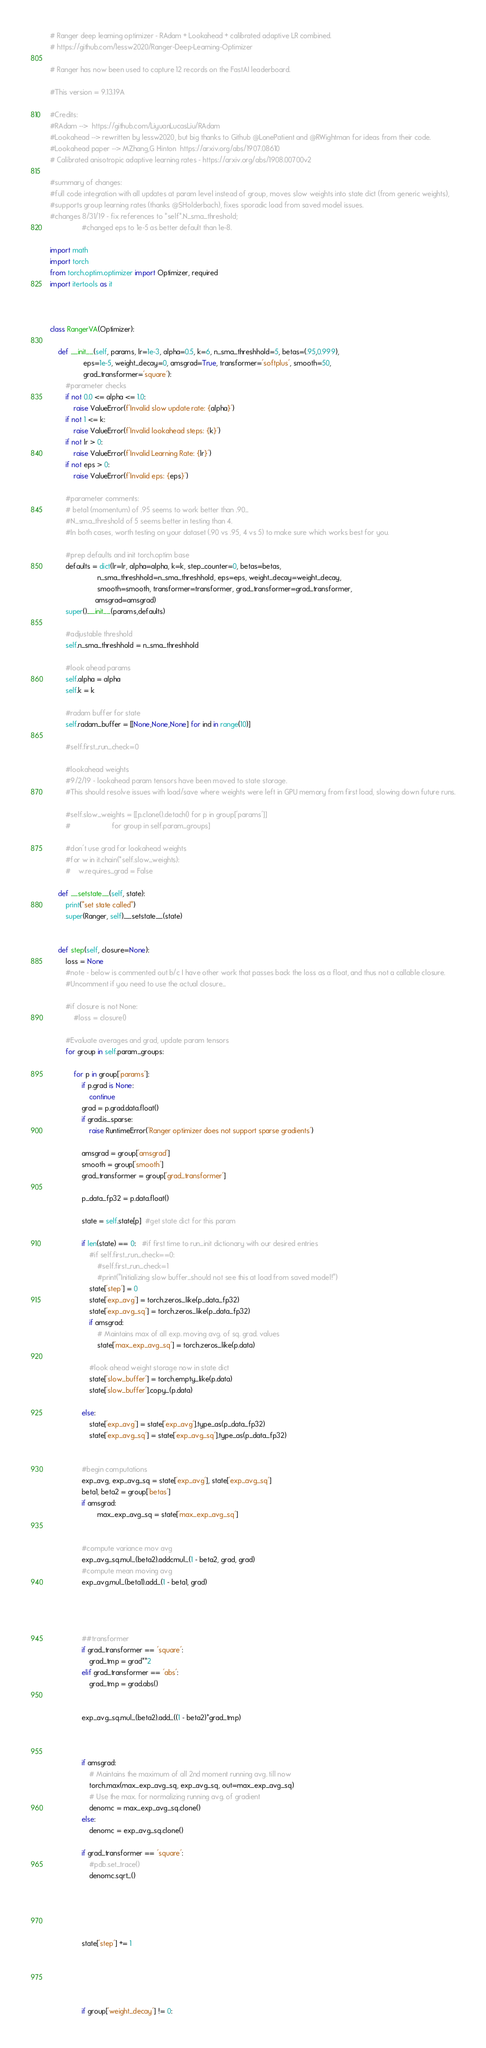Convert code to text. <code><loc_0><loc_0><loc_500><loc_500><_Python_># Ranger deep learning optimizer - RAdam + Lookahead + calibrated adaptive LR combined.
# https://github.com/lessw2020/Ranger-Deep-Learning-Optimizer

# Ranger has now been used to capture 12 records on the FastAI leaderboard.

#This version = 9.13.19A  

#Credits:
#RAdam -->  https://github.com/LiyuanLucasLiu/RAdam
#Lookahead --> rewritten by lessw2020, but big thanks to Github @LonePatient and @RWightman for ideas from their code.
#Lookahead paper --> MZhang,G Hinton  https://arxiv.org/abs/1907.08610
# Calibrated anisotropic adaptive learning rates - https://arxiv.org/abs/1908.00700v2

#summary of changes: 
#full code integration with all updates at param level instead of group, moves slow weights into state dict (from generic weights), 
#supports group learning rates (thanks @SHolderbach), fixes sporadic load from saved model issues.
#changes 8/31/19 - fix references to *self*.N_sma_threshold; 
                #changed eps to 1e-5 as better default than 1e-8.

import math
import torch
from torch.optim.optimizer import Optimizer, required
import itertools as it



class RangerVA(Optimizer):

    def __init__(self, params, lr=1e-3, alpha=0.5, k=6, n_sma_threshhold=5, betas=(.95,0.999), 
                 eps=1e-5, weight_decay=0, amsgrad=True, transformer='softplus', smooth=50,
                 grad_transformer='square'):
        #parameter checks
        if not 0.0 <= alpha <= 1.0:
            raise ValueError(f'Invalid slow update rate: {alpha}')
        if not 1 <= k:
            raise ValueError(f'Invalid lookahead steps: {k}')
        if not lr > 0:
            raise ValueError(f'Invalid Learning Rate: {lr}')
        if not eps > 0:
            raise ValueError(f'Invalid eps: {eps}')

        #parameter comments:
        # beta1 (momentum) of .95 seems to work better than .90...
        #N_sma_threshold of 5 seems better in testing than 4.
        #In both cases, worth testing on your dataset (.90 vs .95, 4 vs 5) to make sure which works best for you.

        #prep defaults and init torch.optim base
        defaults = dict(lr=lr, alpha=alpha, k=k, step_counter=0, betas=betas, 
                        n_sma_threshhold=n_sma_threshhold, eps=eps, weight_decay=weight_decay,
                        smooth=smooth, transformer=transformer, grad_transformer=grad_transformer,
                       amsgrad=amsgrad)
        super().__init__(params,defaults)

        #adjustable threshold
        self.n_sma_threshhold = n_sma_threshhold   

        #look ahead params
        self.alpha = alpha
        self.k = k 

        #radam buffer for state
        self.radam_buffer = [[None,None,None] for ind in range(10)]

        #self.first_run_check=0

        #lookahead weights
        #9/2/19 - lookahead param tensors have been moved to state storage.  
        #This should resolve issues with load/save where weights were left in GPU memory from first load, slowing down future runs.

        #self.slow_weights = [[p.clone().detach() for p in group['params']]
        #                     for group in self.param_groups]

        #don't use grad for lookahead weights
        #for w in it.chain(*self.slow_weights):
        #    w.requires_grad = False

    def __setstate__(self, state):
        print("set state called")
        super(Ranger, self).__setstate__(state)


    def step(self, closure=None):
        loss = None
        #note - below is commented out b/c I have other work that passes back the loss as a float, and thus not a callable closure.  
        #Uncomment if you need to use the actual closure...

        #if closure is not None:
            #loss = closure()

        #Evaluate averages and grad, update param tensors
        for group in self.param_groups:

            for p in group['params']:
                if p.grad is None:
                    continue
                grad = p.grad.data.float()
                if grad.is_sparse:
                    raise RuntimeError('Ranger optimizer does not support sparse gradients')
                
                amsgrad = group['amsgrad']
                smooth = group['smooth']
                grad_transformer = group['grad_transformer']

                p_data_fp32 = p.data.float()

                state = self.state[p]  #get state dict for this param

                if len(state) == 0:   #if first time to run...init dictionary with our desired entries
                    #if self.first_run_check==0:
                        #self.first_run_check=1
                        #print("Initializing slow buffer...should not see this at load from saved model!")
                    state['step'] = 0
                    state['exp_avg'] = torch.zeros_like(p_data_fp32)
                    state['exp_avg_sq'] = torch.zeros_like(p_data_fp32)
                    if amsgrad:
                        # Maintains max of all exp. moving avg. of sq. grad. values
                        state['max_exp_avg_sq'] = torch.zeros_like(p.data)                    

                    #look ahead weight storage now in state dict 
                    state['slow_buffer'] = torch.empty_like(p.data)
                    state['slow_buffer'].copy_(p.data)

                else:
                    state['exp_avg'] = state['exp_avg'].type_as(p_data_fp32)
                    state['exp_avg_sq'] = state['exp_avg_sq'].type_as(p_data_fp32)
                                      

                #begin computations 
                exp_avg, exp_avg_sq = state['exp_avg'], state['exp_avg_sq']
                beta1, beta2 = group['betas']
                if amsgrad:
                        max_exp_avg_sq = state['max_exp_avg_sq']  
                                

                #compute variance mov avg
                exp_avg_sq.mul_(beta2).addcmul_(1 - beta2, grad, grad)
                #compute mean moving avg
                exp_avg.mul_(beta1).add_(1 - beta1, grad)
                
               
                
                
                ##transformer
                if grad_transformer == 'square':
                    grad_tmp = grad**2
                elif grad_transformer == 'abs':
                    grad_tmp = grad.abs()


                exp_avg_sq.mul_(beta2).add_((1 - beta2)*grad_tmp)



                if amsgrad:
                    # Maintains the maximum of all 2nd moment running avg. till now
                    torch.max(max_exp_avg_sq, exp_avg_sq, out=max_exp_avg_sq)
                    # Use the max. for normalizing running avg. of gradient
                    denomc = max_exp_avg_sq.clone()
                else:
                    denomc = exp_avg_sq.clone()

                if grad_transformer == 'square':
                    #pdb.set_trace()
                    denomc.sqrt_()                 
                
                
                
                                

                state['step'] += 1
                
                

               

                if group['weight_decay'] != 0:</code> 